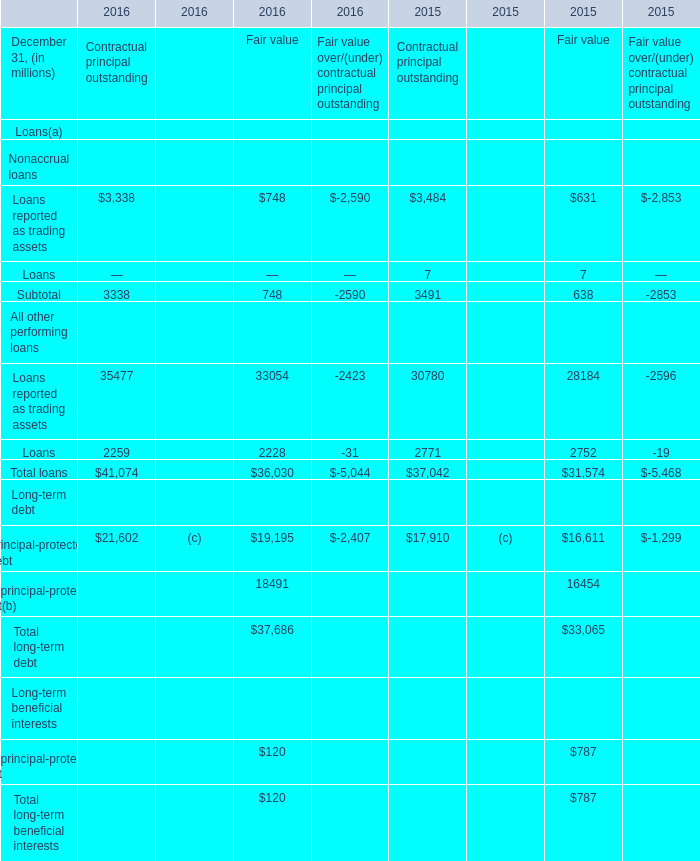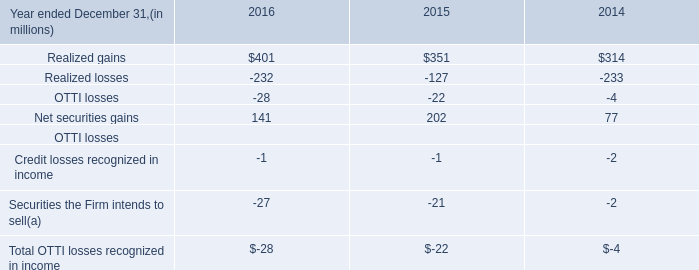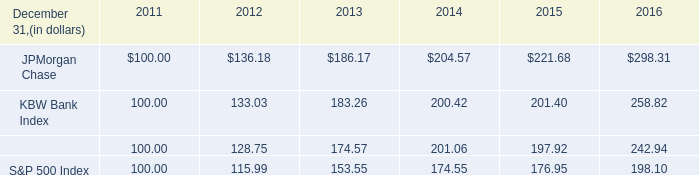what was the 5 year return of jpmorgan chase's stock? 
Computations: ((298.31 - 100) / 100)
Answer: 1.9831. 